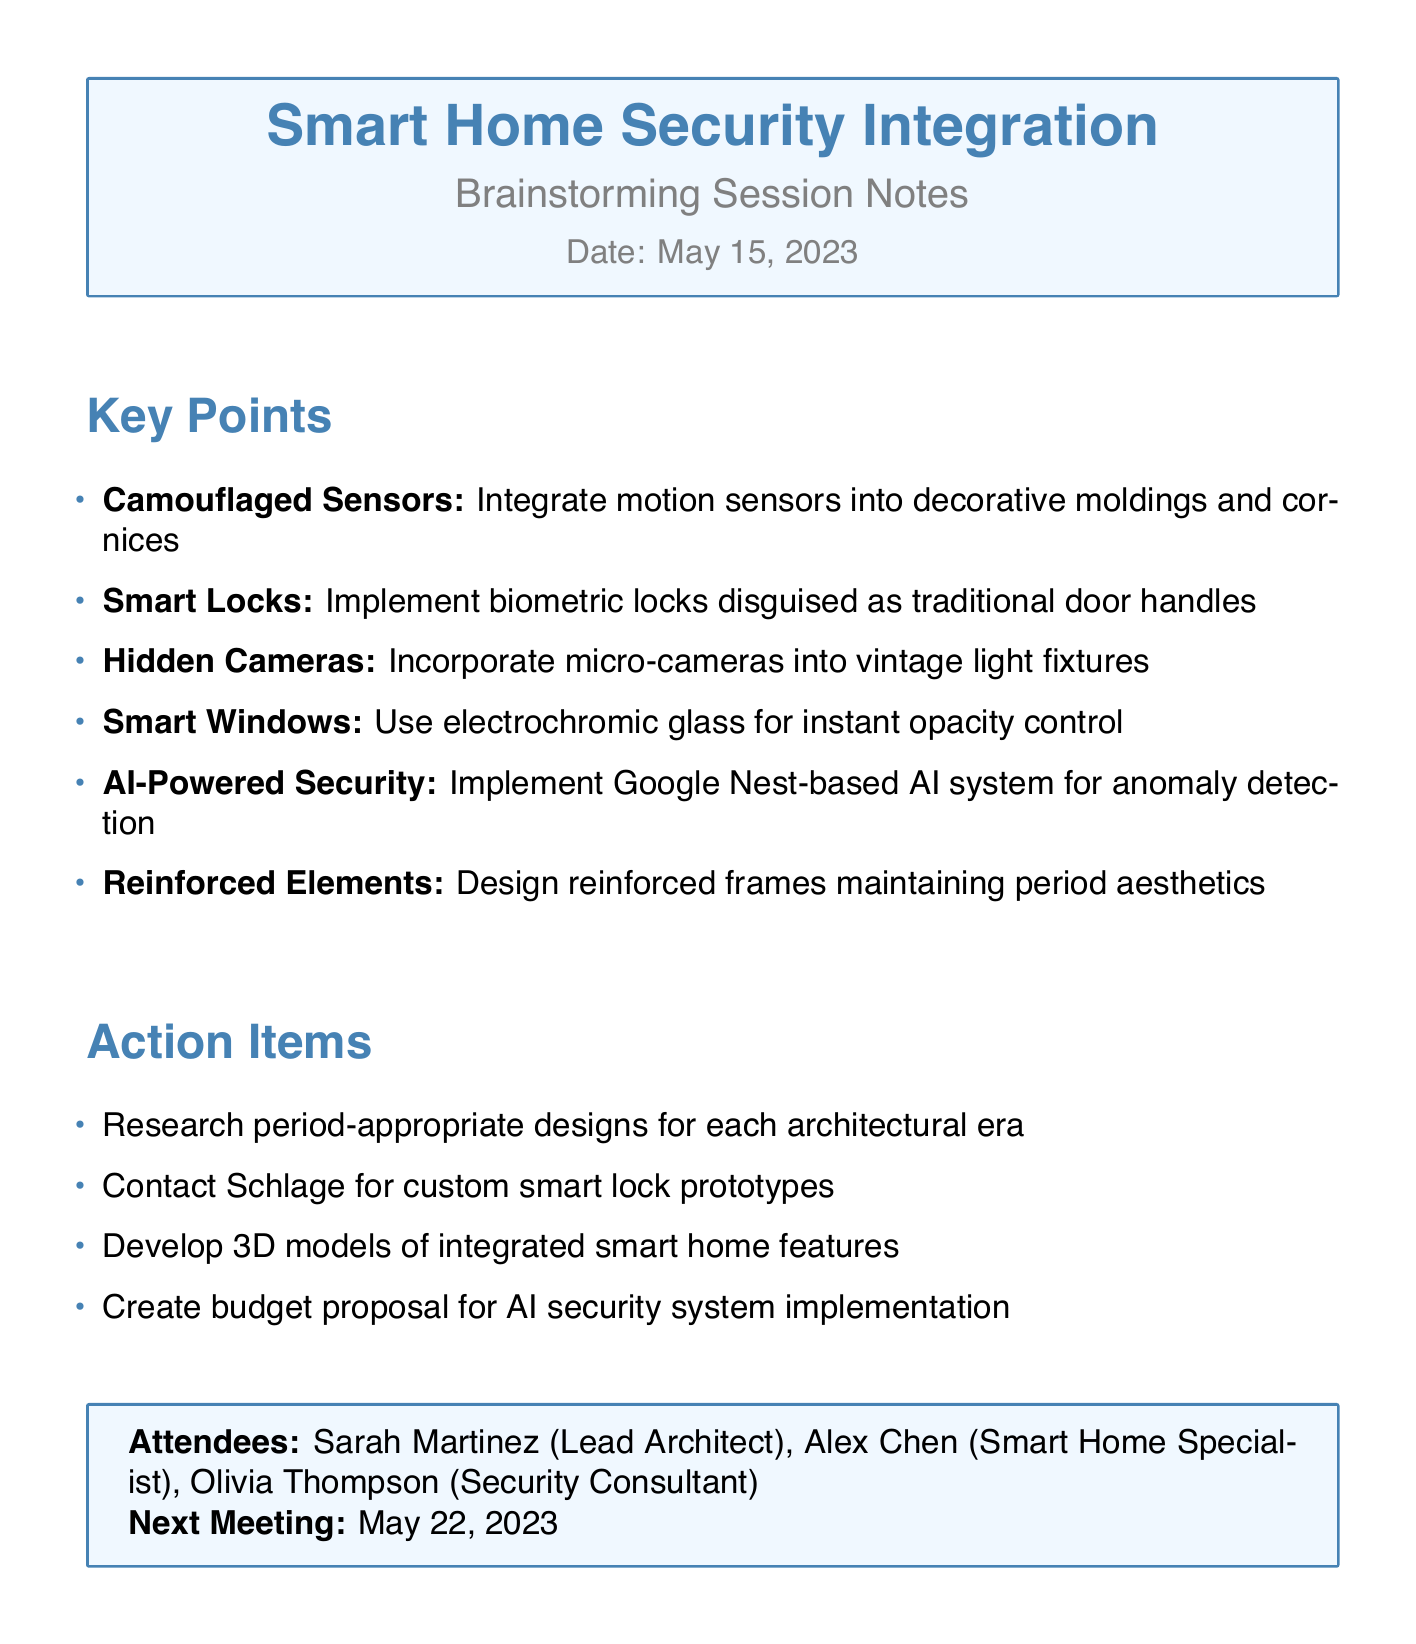What is the session title? The session title is explicitly stated at the beginning of the document.
Answer: Integrating Smart Home Tech with Traditional Architecture for Enhanced Security Who is the Lead Architect? The attendees list identifies Sarah Martinez as the Lead Architect.
Answer: Sarah Martinez What date was the brainstorming session held? The date is clearly mentioned in the header of the document.
Answer: 2023-05-15 How many key points are listed? The number of key points can be counted in the Key Points section of the document.
Answer: Six What is one method for incorporating hidden cameras? A specific detail regarding the incorporation of hidden cameras is provided in the key points.
Answer: Into vintage light fixtures What is one action item from the notes? The action items section lists specific tasks to be completed after the meeting.
Answer: Research period-appropriate designs for each architectural era What technology is suggested for windows? The details regarding the windows can be found in the Key Points section.
Answer: Electrochromic glass What did the group plan to do for custom smart locks? The action item relating to custom smart locks is mentioned in the action items.
Answer: Contact Schlage for custom smart lock prototypes When is the next meeting scheduled? The date for the next meeting is provided in the concluding box of the document.
Answer: 2023-05-22 